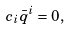<formula> <loc_0><loc_0><loc_500><loc_500>c _ { i } \bar { q } ^ { i } = 0 ,</formula> 